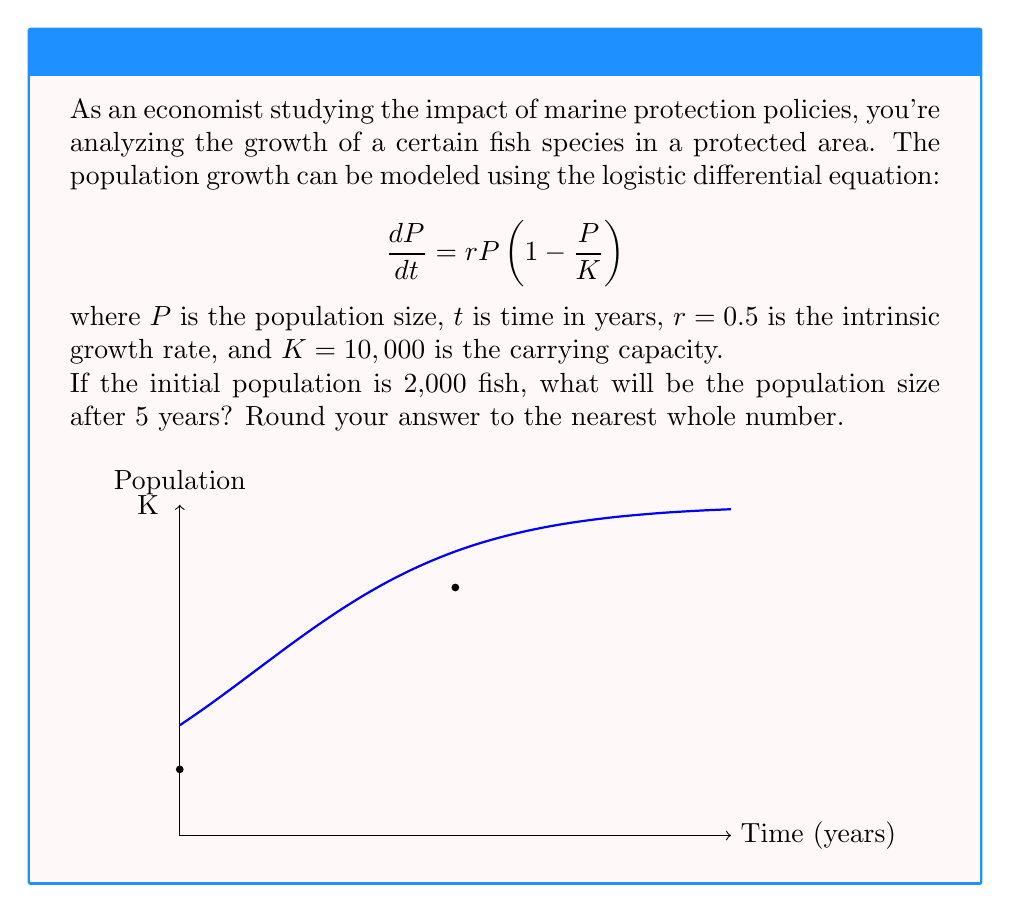Help me with this question. To solve this problem, we need to use the solution to the logistic differential equation:

$$P(t) = \frac{K}{1 + (\frac{K}{P_0} - 1)e^{-rt}}$$

where $P_0$ is the initial population.

Given:
- $K = 10,000$ (carrying capacity)
- $r = 0.5$ (intrinsic growth rate)
- $P_0 = 2,000$ (initial population)
- $t = 5$ (time in years)

Let's solve step by step:

1) Substitute the values into the equation:

   $$P(5) = \frac{10,000}{1 + (\frac{10,000}{2,000} - 1)e^{-0.5 \cdot 5}}$$

2) Simplify:

   $$P(5) = \frac{10,000}{1 + (5 - 1)e^{-2.5}}$$
   
   $$P(5) = \frac{10,000}{1 + 4e^{-2.5}}$$

3) Calculate $e^{-2.5}$:

   $$e^{-2.5} \approx 0.0821$$

4) Substitute this value:

   $$P(5) = \frac{10,000}{1 + 4(0.0821)}$$
   
   $$P(5) = \frac{10,000}{1 + 0.3284}$$
   
   $$P(5) = \frac{10,000}{1.3284}$$

5) Calculate the final result:

   $$P(5) \approx 7,528.15$$

6) Rounding to the nearest whole number:

   $$P(5) \approx 7,528$$

Therefore, after 5 years, the fish population will be approximately 7,528.
Answer: 7,528 fish 